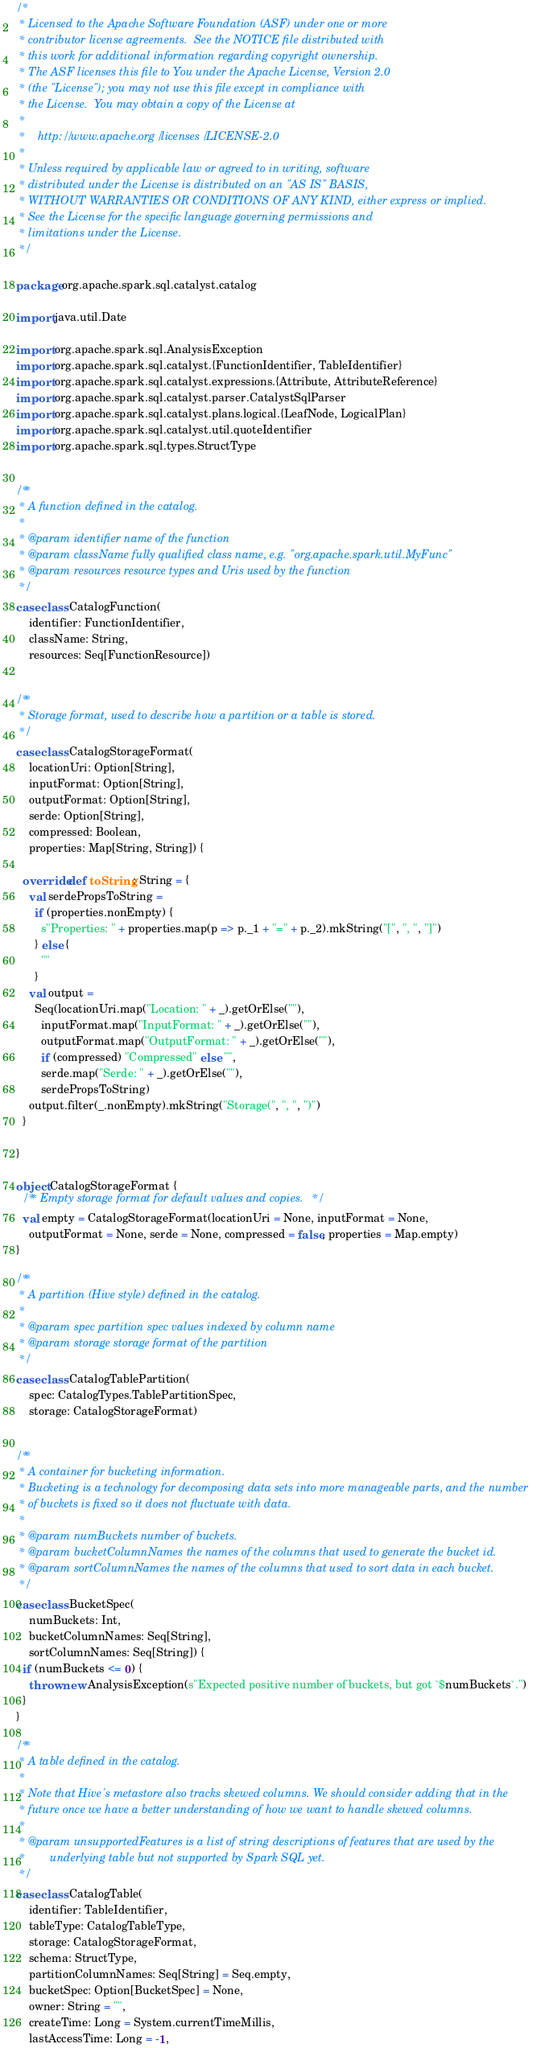Convert code to text. <code><loc_0><loc_0><loc_500><loc_500><_Scala_>/*
 * Licensed to the Apache Software Foundation (ASF) under one or more
 * contributor license agreements.  See the NOTICE file distributed with
 * this work for additional information regarding copyright ownership.
 * The ASF licenses this file to You under the Apache License, Version 2.0
 * (the "License"); you may not use this file except in compliance with
 * the License.  You may obtain a copy of the License at
 *
 *    http://www.apache.org/licenses/LICENSE-2.0
 *
 * Unless required by applicable law or agreed to in writing, software
 * distributed under the License is distributed on an "AS IS" BASIS,
 * WITHOUT WARRANTIES OR CONDITIONS OF ANY KIND, either express or implied.
 * See the License for the specific language governing permissions and
 * limitations under the License.
 */

package org.apache.spark.sql.catalyst.catalog

import java.util.Date

import org.apache.spark.sql.AnalysisException
import org.apache.spark.sql.catalyst.{FunctionIdentifier, TableIdentifier}
import org.apache.spark.sql.catalyst.expressions.{Attribute, AttributeReference}
import org.apache.spark.sql.catalyst.parser.CatalystSqlParser
import org.apache.spark.sql.catalyst.plans.logical.{LeafNode, LogicalPlan}
import org.apache.spark.sql.catalyst.util.quoteIdentifier
import org.apache.spark.sql.types.StructType


/**
 * A function defined in the catalog.
 *
 * @param identifier name of the function
 * @param className fully qualified class name, e.g. "org.apache.spark.util.MyFunc"
 * @param resources resource types and Uris used by the function
 */
case class CatalogFunction(
    identifier: FunctionIdentifier,
    className: String,
    resources: Seq[FunctionResource])


/**
 * Storage format, used to describe how a partition or a table is stored.
 */
case class CatalogStorageFormat(
    locationUri: Option[String],
    inputFormat: Option[String],
    outputFormat: Option[String],
    serde: Option[String],
    compressed: Boolean,
    properties: Map[String, String]) {

  override def toString: String = {
    val serdePropsToString =
      if (properties.nonEmpty) {
        s"Properties: " + properties.map(p => p._1 + "=" + p._2).mkString("[", ", ", "]")
      } else {
        ""
      }
    val output =
      Seq(locationUri.map("Location: " + _).getOrElse(""),
        inputFormat.map("InputFormat: " + _).getOrElse(""),
        outputFormat.map("OutputFormat: " + _).getOrElse(""),
        if (compressed) "Compressed" else "",
        serde.map("Serde: " + _).getOrElse(""),
        serdePropsToString)
    output.filter(_.nonEmpty).mkString("Storage(", ", ", ")")
  }

}

object CatalogStorageFormat {
  /** Empty storage format for default values and copies. */
  val empty = CatalogStorageFormat(locationUri = None, inputFormat = None,
    outputFormat = None, serde = None, compressed = false, properties = Map.empty)
}

/**
 * A partition (Hive style) defined in the catalog.
 *
 * @param spec partition spec values indexed by column name
 * @param storage storage format of the partition
 */
case class CatalogTablePartition(
    spec: CatalogTypes.TablePartitionSpec,
    storage: CatalogStorageFormat)


/**
 * A container for bucketing information.
 * Bucketing is a technology for decomposing data sets into more manageable parts, and the number
 * of buckets is fixed so it does not fluctuate with data.
 *
 * @param numBuckets number of buckets.
 * @param bucketColumnNames the names of the columns that used to generate the bucket id.
 * @param sortColumnNames the names of the columns that used to sort data in each bucket.
 */
case class BucketSpec(
    numBuckets: Int,
    bucketColumnNames: Seq[String],
    sortColumnNames: Seq[String]) {
  if (numBuckets <= 0) {
    throw new AnalysisException(s"Expected positive number of buckets, but got `$numBuckets`.")
  }
}

/**
 * A table defined in the catalog.
 *
 * Note that Hive's metastore also tracks skewed columns. We should consider adding that in the
 * future once we have a better understanding of how we want to handle skewed columns.
 *
 * @param unsupportedFeatures is a list of string descriptions of features that are used by the
 *        underlying table but not supported by Spark SQL yet.
 */
case class CatalogTable(
    identifier: TableIdentifier,
    tableType: CatalogTableType,
    storage: CatalogStorageFormat,
    schema: StructType,
    partitionColumnNames: Seq[String] = Seq.empty,
    bucketSpec: Option[BucketSpec] = None,
    owner: String = "",
    createTime: Long = System.currentTimeMillis,
    lastAccessTime: Long = -1,</code> 